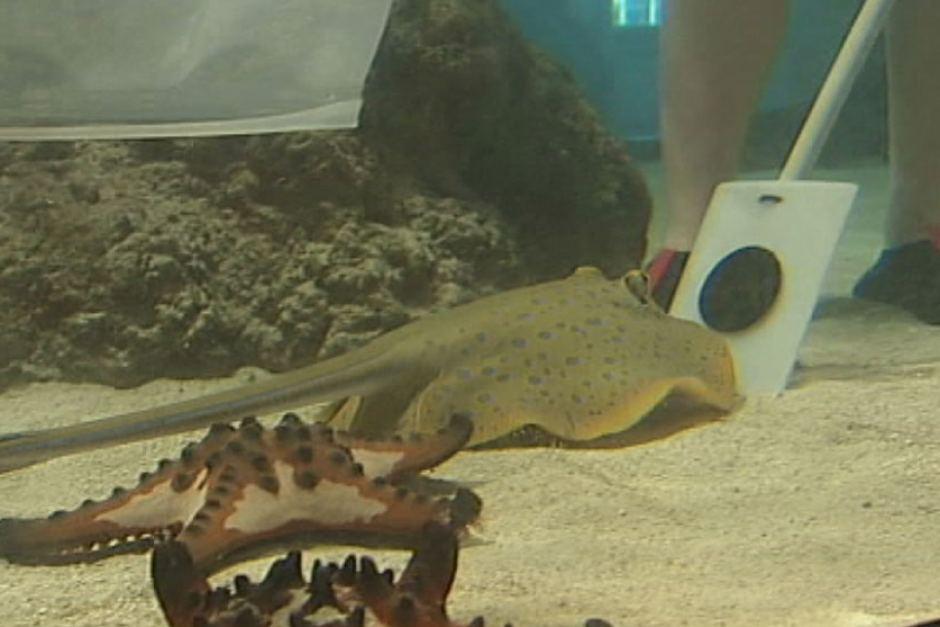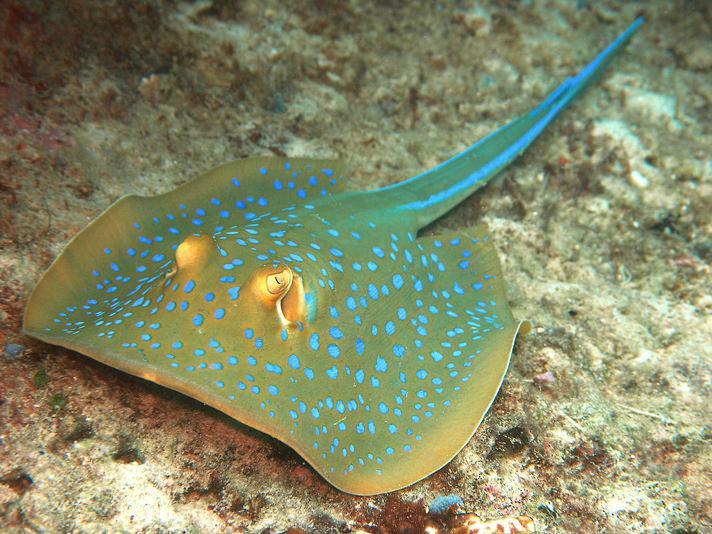The first image is the image on the left, the second image is the image on the right. Assess this claim about the two images: "In the left image, a fish is visible in the tank with a sting ray.". Correct or not? Answer yes or no. No. 